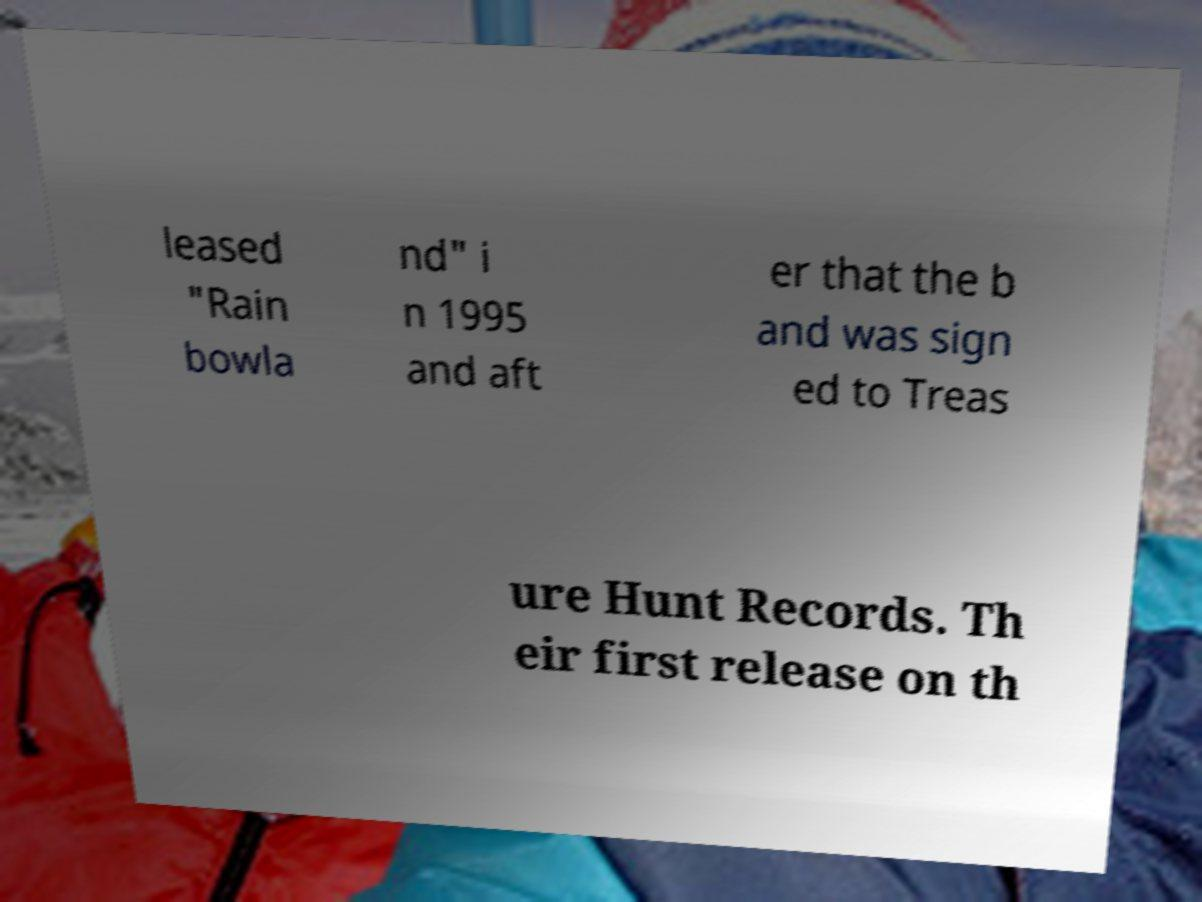Could you assist in decoding the text presented in this image and type it out clearly? leased "Rain bowla nd" i n 1995 and aft er that the b and was sign ed to Treas ure Hunt Records. Th eir first release on th 